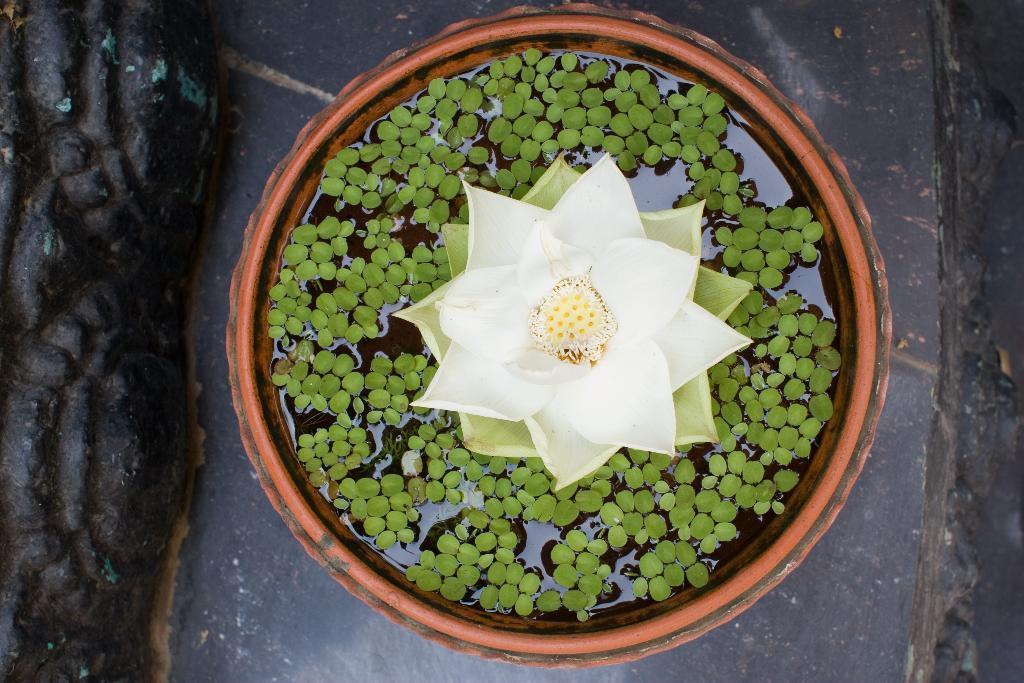Please provide a concise description of this image. In this picture we can see the pot on which there is a flower with some leaves. 